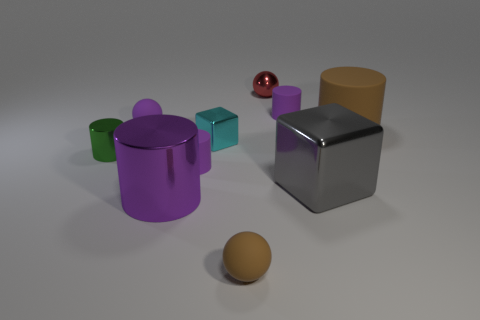Subtract all green balls. How many purple cylinders are left? 3 Subtract all brown matte spheres. How many spheres are left? 2 Subtract 1 spheres. How many spheres are left? 2 Subtract all brown cylinders. How many cylinders are left? 4 Subtract all gray cylinders. Subtract all brown spheres. How many cylinders are left? 5 Subtract all blocks. How many objects are left? 8 Add 2 brown blocks. How many brown blocks exist? 2 Subtract 1 cyan cubes. How many objects are left? 9 Subtract all small purple matte cylinders. Subtract all small cyan blocks. How many objects are left? 7 Add 3 small metallic cubes. How many small metallic cubes are left? 4 